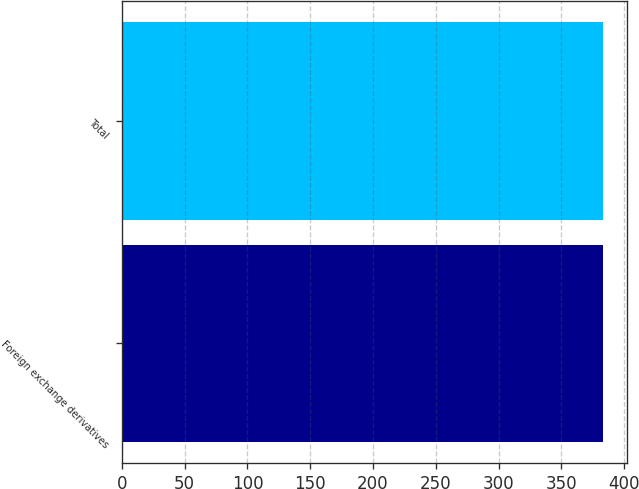Convert chart to OTSL. <chart><loc_0><loc_0><loc_500><loc_500><bar_chart><fcel>Foreign exchange derivatives<fcel>Total<nl><fcel>383<fcel>383.1<nl></chart> 